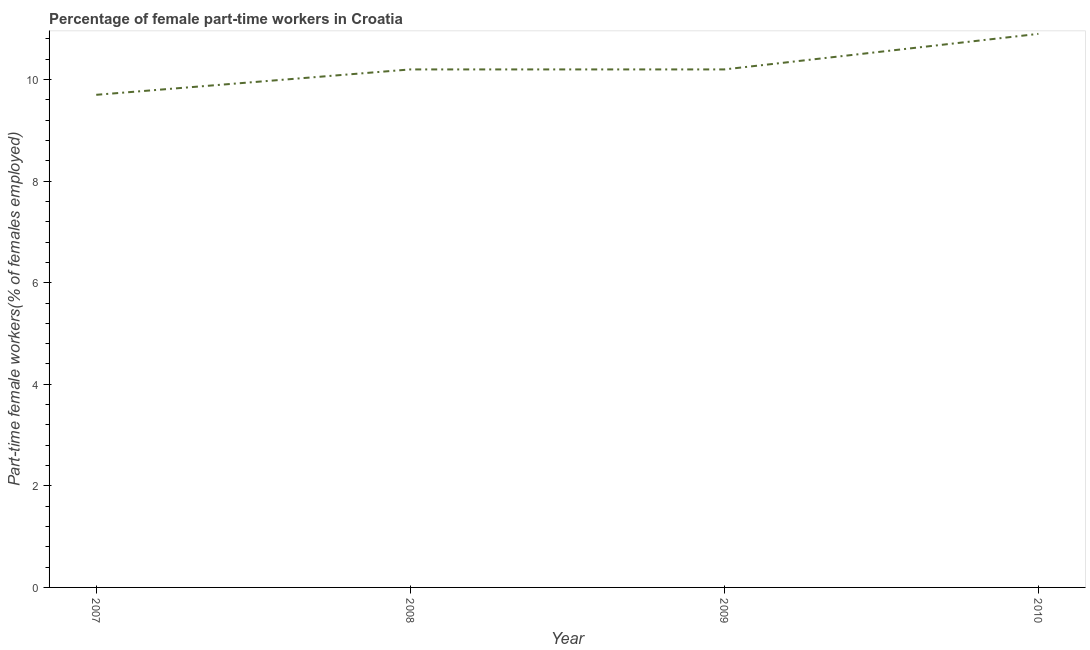What is the percentage of part-time female workers in 2009?
Your answer should be very brief. 10.2. Across all years, what is the maximum percentage of part-time female workers?
Your answer should be compact. 10.9. Across all years, what is the minimum percentage of part-time female workers?
Ensure brevity in your answer.  9.7. In which year was the percentage of part-time female workers minimum?
Give a very brief answer. 2007. What is the sum of the percentage of part-time female workers?
Keep it short and to the point. 41. What is the difference between the percentage of part-time female workers in 2007 and 2010?
Your answer should be compact. -1.2. What is the average percentage of part-time female workers per year?
Your answer should be compact. 10.25. What is the median percentage of part-time female workers?
Offer a very short reply. 10.2. In how many years, is the percentage of part-time female workers greater than 7.2 %?
Ensure brevity in your answer.  4. What is the ratio of the percentage of part-time female workers in 2008 to that in 2009?
Make the answer very short. 1. Is the percentage of part-time female workers in 2009 less than that in 2010?
Make the answer very short. Yes. What is the difference between the highest and the second highest percentage of part-time female workers?
Make the answer very short. 0.7. What is the difference between the highest and the lowest percentage of part-time female workers?
Your answer should be very brief. 1.2. Does the percentage of part-time female workers monotonically increase over the years?
Give a very brief answer. No. How many years are there in the graph?
Give a very brief answer. 4. Does the graph contain any zero values?
Provide a succinct answer. No. What is the title of the graph?
Provide a short and direct response. Percentage of female part-time workers in Croatia. What is the label or title of the X-axis?
Give a very brief answer. Year. What is the label or title of the Y-axis?
Your answer should be very brief. Part-time female workers(% of females employed). What is the Part-time female workers(% of females employed) of 2007?
Keep it short and to the point. 9.7. What is the Part-time female workers(% of females employed) of 2008?
Provide a succinct answer. 10.2. What is the Part-time female workers(% of females employed) of 2009?
Your response must be concise. 10.2. What is the Part-time female workers(% of females employed) in 2010?
Your answer should be very brief. 10.9. What is the difference between the Part-time female workers(% of females employed) in 2007 and 2009?
Your answer should be very brief. -0.5. What is the difference between the Part-time female workers(% of females employed) in 2007 and 2010?
Keep it short and to the point. -1.2. What is the difference between the Part-time female workers(% of females employed) in 2008 and 2010?
Your answer should be very brief. -0.7. What is the ratio of the Part-time female workers(% of females employed) in 2007 to that in 2008?
Your response must be concise. 0.95. What is the ratio of the Part-time female workers(% of females employed) in 2007 to that in 2009?
Give a very brief answer. 0.95. What is the ratio of the Part-time female workers(% of females employed) in 2007 to that in 2010?
Offer a very short reply. 0.89. What is the ratio of the Part-time female workers(% of females employed) in 2008 to that in 2010?
Keep it short and to the point. 0.94. What is the ratio of the Part-time female workers(% of females employed) in 2009 to that in 2010?
Give a very brief answer. 0.94. 